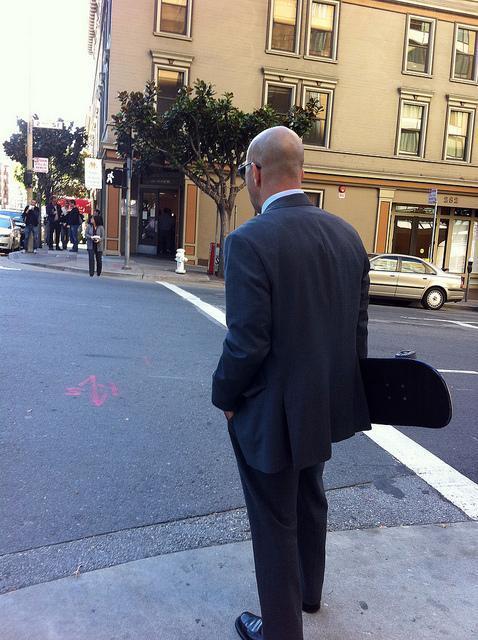How many plates with cake are shown in this picture?
Give a very brief answer. 0. 